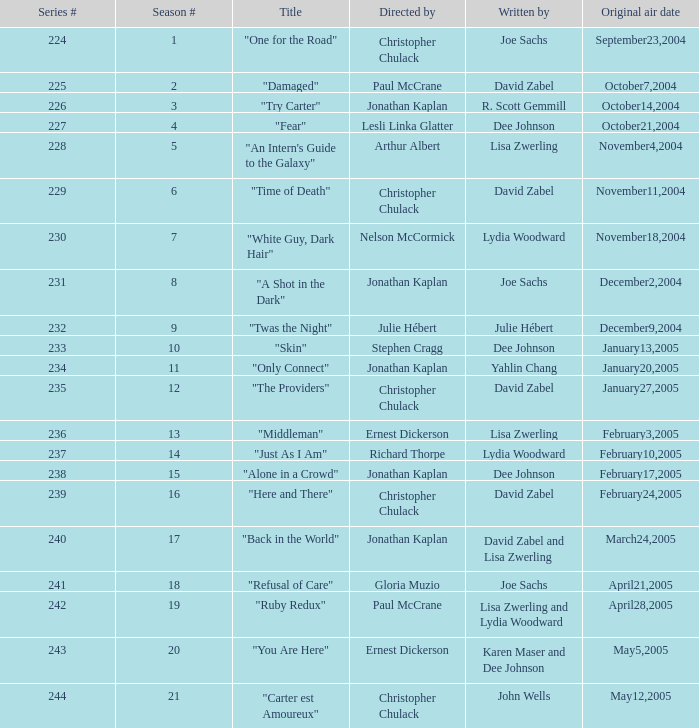Who is the writer of the episode directed by arthur albert? Lisa Zwerling. 